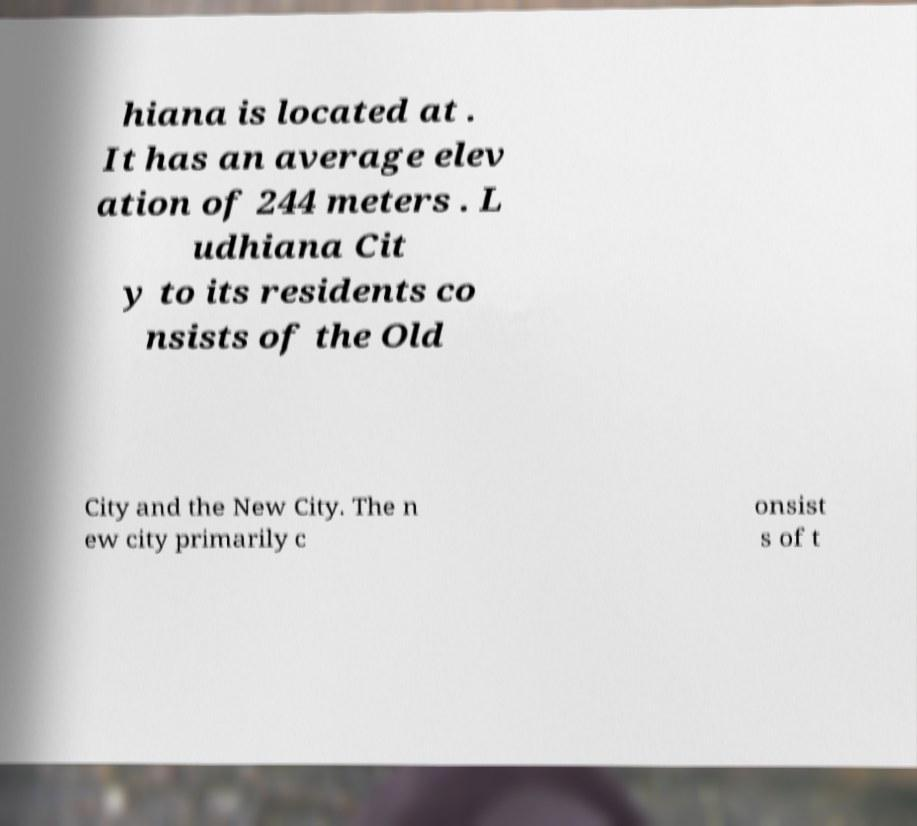Can you read and provide the text displayed in the image?This photo seems to have some interesting text. Can you extract and type it out for me? hiana is located at . It has an average elev ation of 244 meters . L udhiana Cit y to its residents co nsists of the Old City and the New City. The n ew city primarily c onsist s of t 